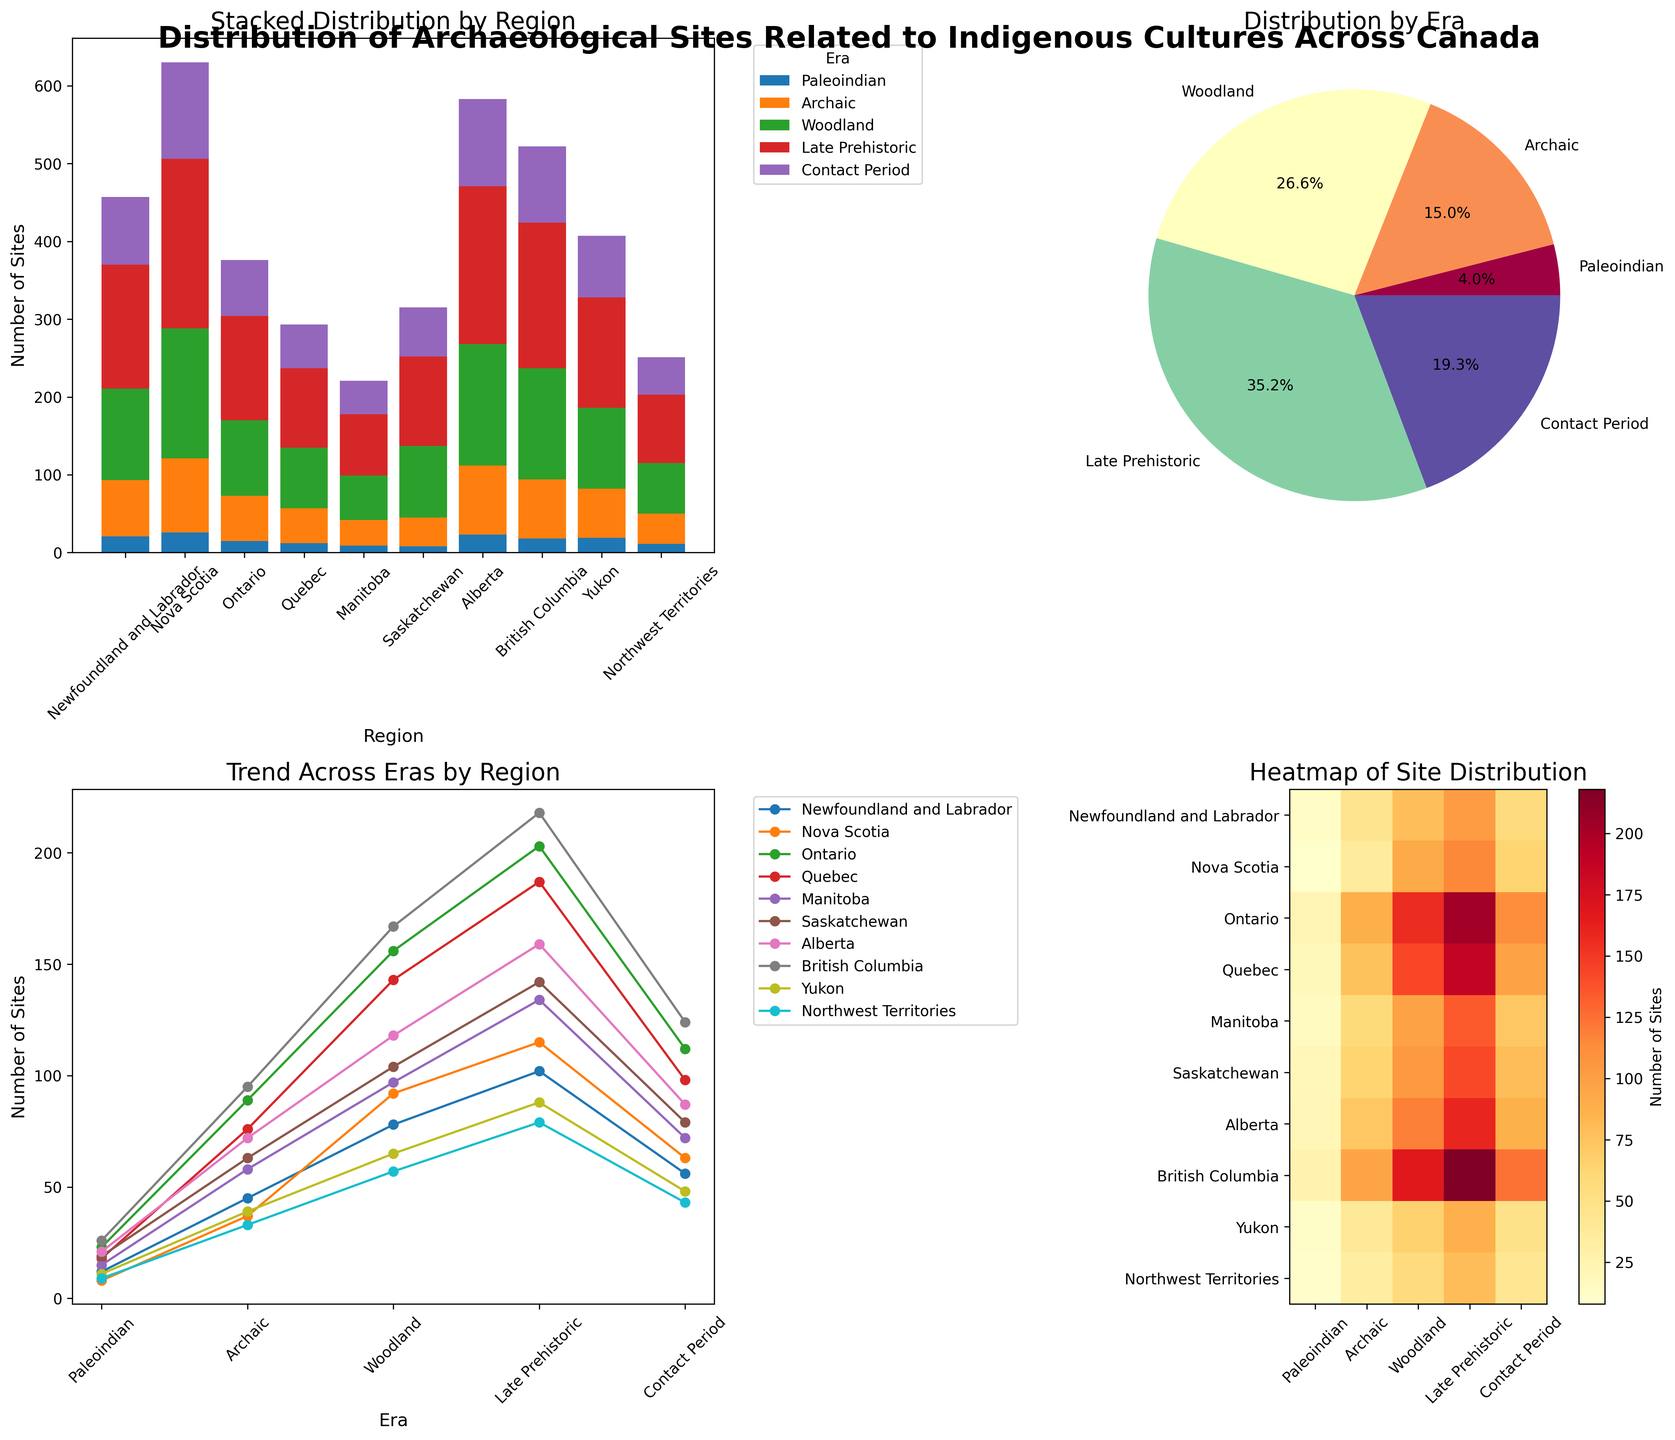what is the title of the figure? The title of the figure is located at the very top in bold font, providing a summary of the entire diagram.
Answer: Distribution of Archaeological Sites Related to Indigenous Cultures Across Canada Which region has the highest total number of archaeological sites in the stacked bar chart? Check the height of the stacked bars in the bar chart to find the region with the highest total, which appears to be the Western region.
Answer: Western What is the percentage of archaeological sites from the Archaic era in the pie chart? Look at the pie chart specifically and identify the segment labeled "Archaic." The percentage shown within this segment is 19.2%.
Answer: 19.2% Describe the overall trend for the number of sites in each region over different eras in the line plot. The line plot shows the number of sites for different regions across eras. Most regions exhibit an increasing trend from Paleoindian to Contact Period, demonstrating that more archaeological sites have been identified from recent eras.
Answer: Increasing How does the number of Woodland era sites compare between Newfoundland and Labrador and British Columbia in the heatmap? Find and compare the respective cells under the Woodland era column for both regions. Newfoundland and Labrador show 78 sites, while British Columbia shows 167 sites, indicating that British Columbia has more sites from the Woodland era.
Answer: British Columbia has more What era shows the highest number of archaeological sites overall in the pie chart? Observe the pie chart and look for the largest segment percentage-wise, which is the Late Prehistoric era at 25.4%.
Answer: Late Prehistoric How many more archaeological sites are there in Alberta compared to Manitoba during the Contact Period based on the line plot? Look at the line plot for the Contact Period era and compare the data points for Alberta and Manitoba. Alberta has 87, and Manitoba has 72 sites. The difference is 87 - 72 = 15.
Answer: 15 In which region does the count of sites decrease from the Woodland era to the Late Prehistoric era according to the heatmap? Check the values in the heatmap for each region between Woodland and Late Prehistoric eras. Only the Northwest Territories show a decrease from 57 to 79 sites.
Answer: Northwest Territories What is the sum of archaeological sites across all eras in Saskatchewan and Nova Scotia from the stacked bar chart? Add the counts from the stacked bar chart for both these regions across all eras. Saskatchewan: 19+63+104+142+79 = 407. Nova Scotia: 8+37+92+115+63 = 315. The total is 407 + 315 = 722.
Answer: 722 Which era has the least representation in the dataset according to the pie chart? Check the smallest segment of the pie chart, which corresponds to the era with the smallest percentage representation. This is the Paleoindian era at 6.5%.
Answer: Paleoindian 